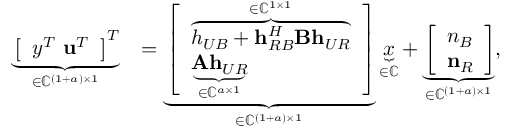Convert formula to latex. <formula><loc_0><loc_0><loc_500><loc_500>\begin{array} { r l } { \underbrace { \left [ \begin{array} { l } { y ^ { T } \ u ^ { T } } \end{array} \right ] ^ { T } } _ { \in \mathbb { C } ^ { ( 1 + a ) \times 1 } } } & { = \underbrace { \left [ \begin{array} { l } { \overbrace { h _ { U B } + h _ { R B } ^ { H } B h _ { U R } } ^ { \in \mathbb { C } ^ { 1 \times 1 } } } \\ { \underbrace { A h _ { U R } } _ { \in \mathbb { C } ^ { a \times 1 } } } \end{array} \right ] } _ { \in \mathbb { C } ^ { ( 1 + a ) \times 1 } } \underbrace { x } _ { \in \mathbb { C } } + \underbrace { \left [ \begin{array} { l } { n _ { B } } \\ { n _ { R } } \end{array} \right ] } _ { \in \mathbb { C } ^ { ( 1 + a ) \times 1 } } , } \end{array}</formula> 